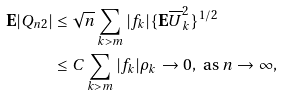Convert formula to latex. <formula><loc_0><loc_0><loc_500><loc_500>\mathbf E | Q _ { n 2 } | & \leq { \sqrt { n } } \sum _ { k > m } | f _ { k } | \{ \mathbf E \overline { U } _ { k } ^ { 2 } \} ^ { 1 / 2 } \\ & \leq C \sum _ { k > m } | f _ { k } | \rho _ { k } \to 0 , \text { as } n \to \infty ,</formula> 